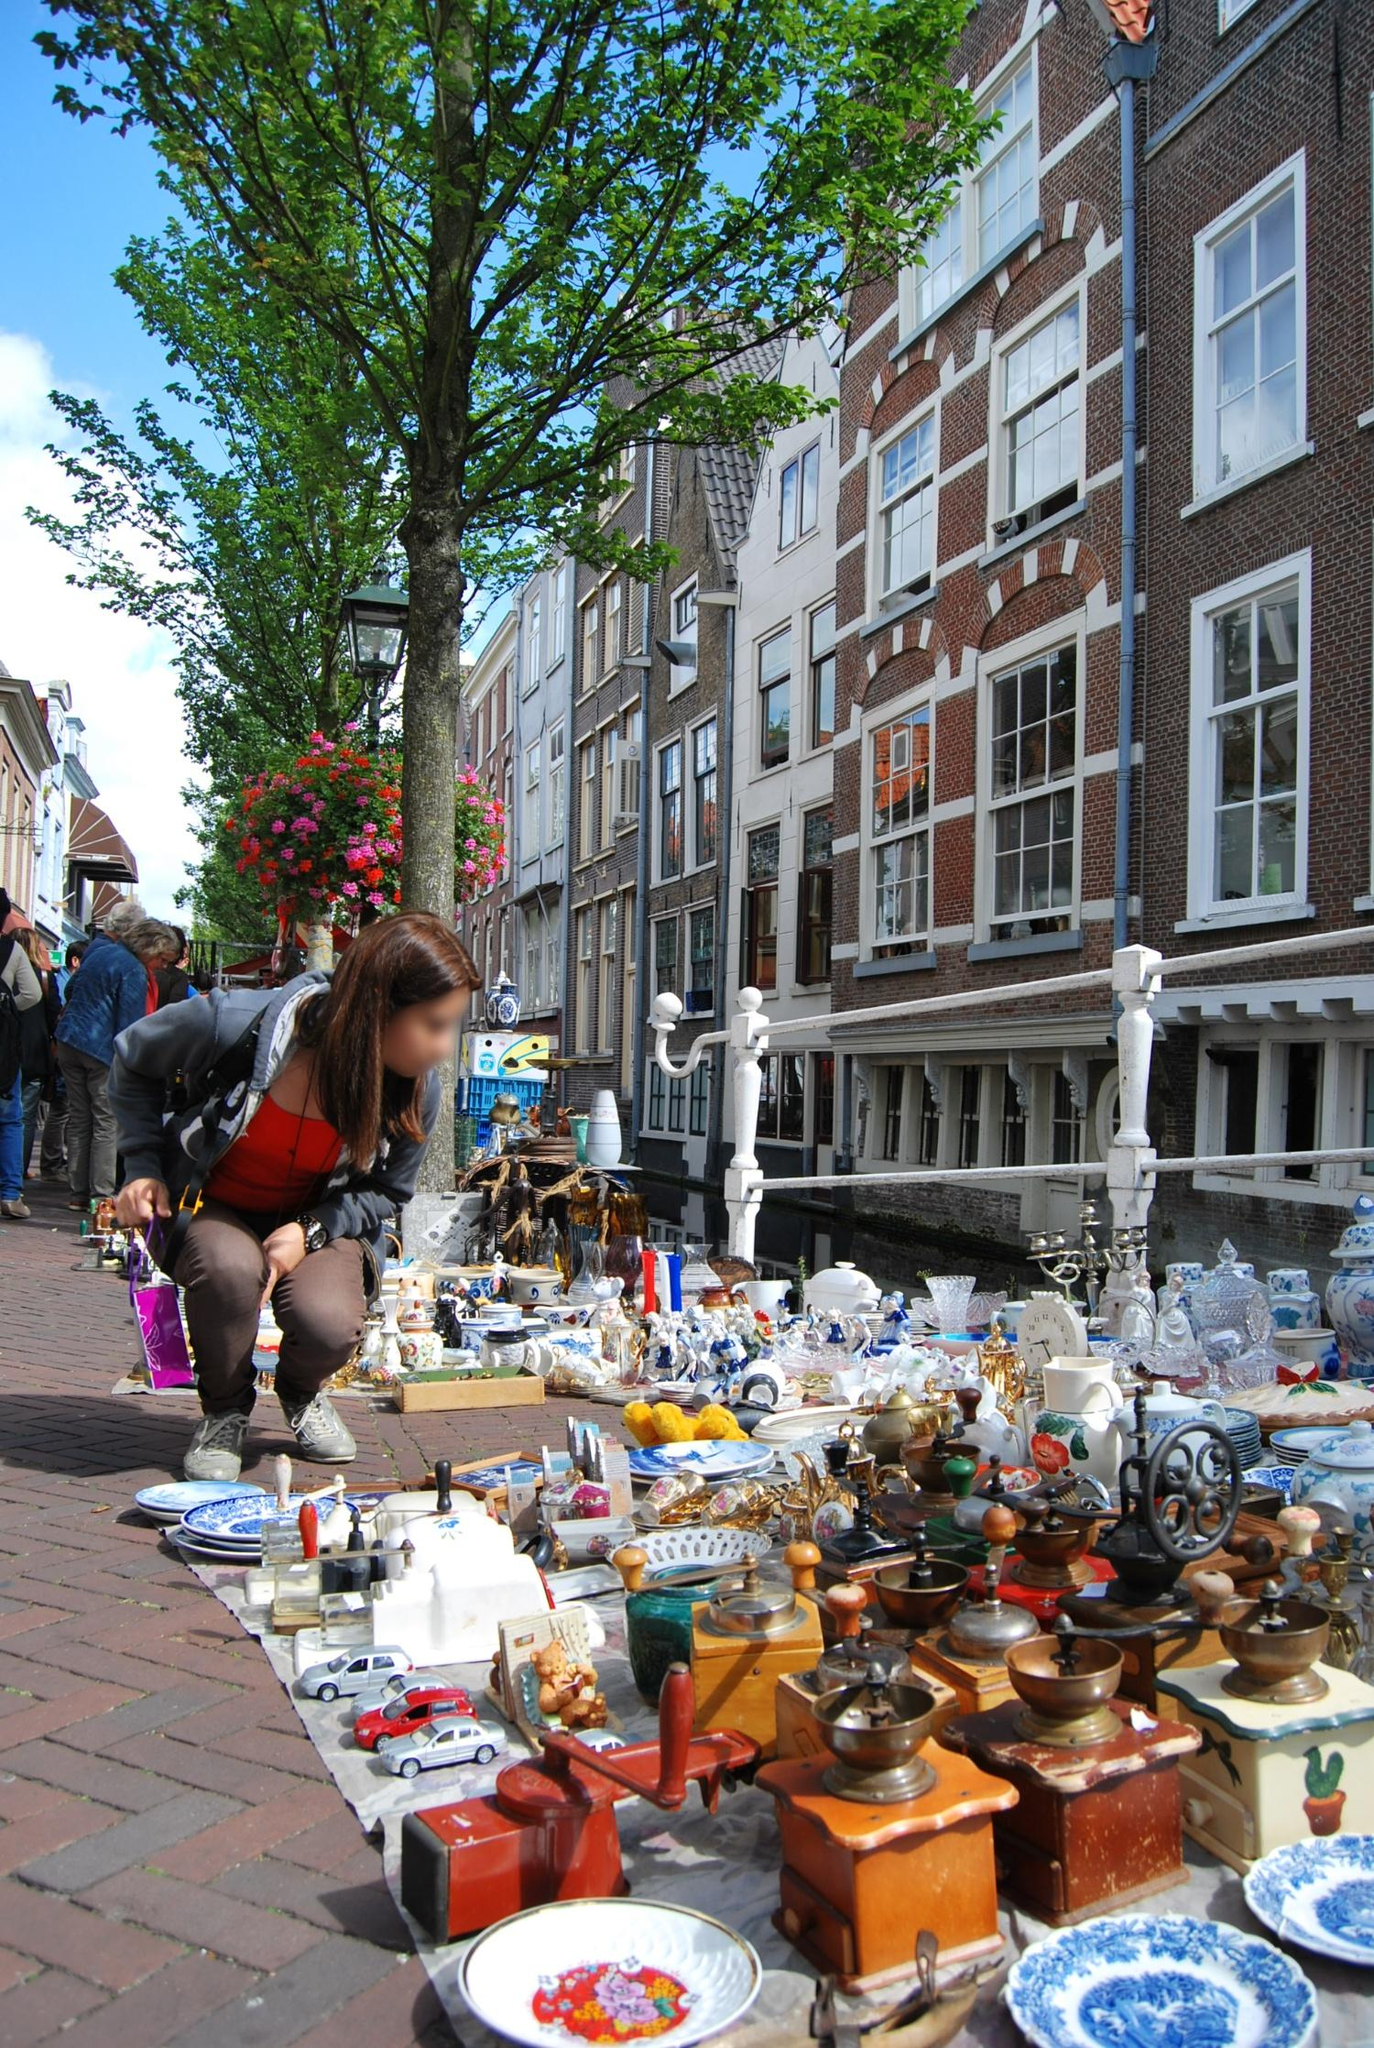What modern-day scenarios could a tourist visiting this street market in Amsterdam experience? A tourist visiting this street market in Amsterdam would likely experience a vibrant blend of sights, sounds, and smells, characteristic of a lively urban market. As they meander through the narrow streets lined with stalls, they might come across vendors selling an array of items, from unique crafts and antiques to fresh produce and local delicacies. The air would be filled with the aroma of freshly baked Stroopwafels, a popular Dutch treat, enticing them to stop and enjoy a warm, caramel-filled waffle.

Friendly interactions with the local vendors, who often share stories about their wares and culture, create a welcoming atmosphere. The tourist might also hear a street musician playing traditional or contemporary tunes that add to the market's vibrant ambience. Surrounded by the historic backdrop of Amsterdam's charming architecture, they would likely indulge in taking pictures, shopping for souvenirs, and savoring the local foods, making for a memorable and immersive cultural experience. 